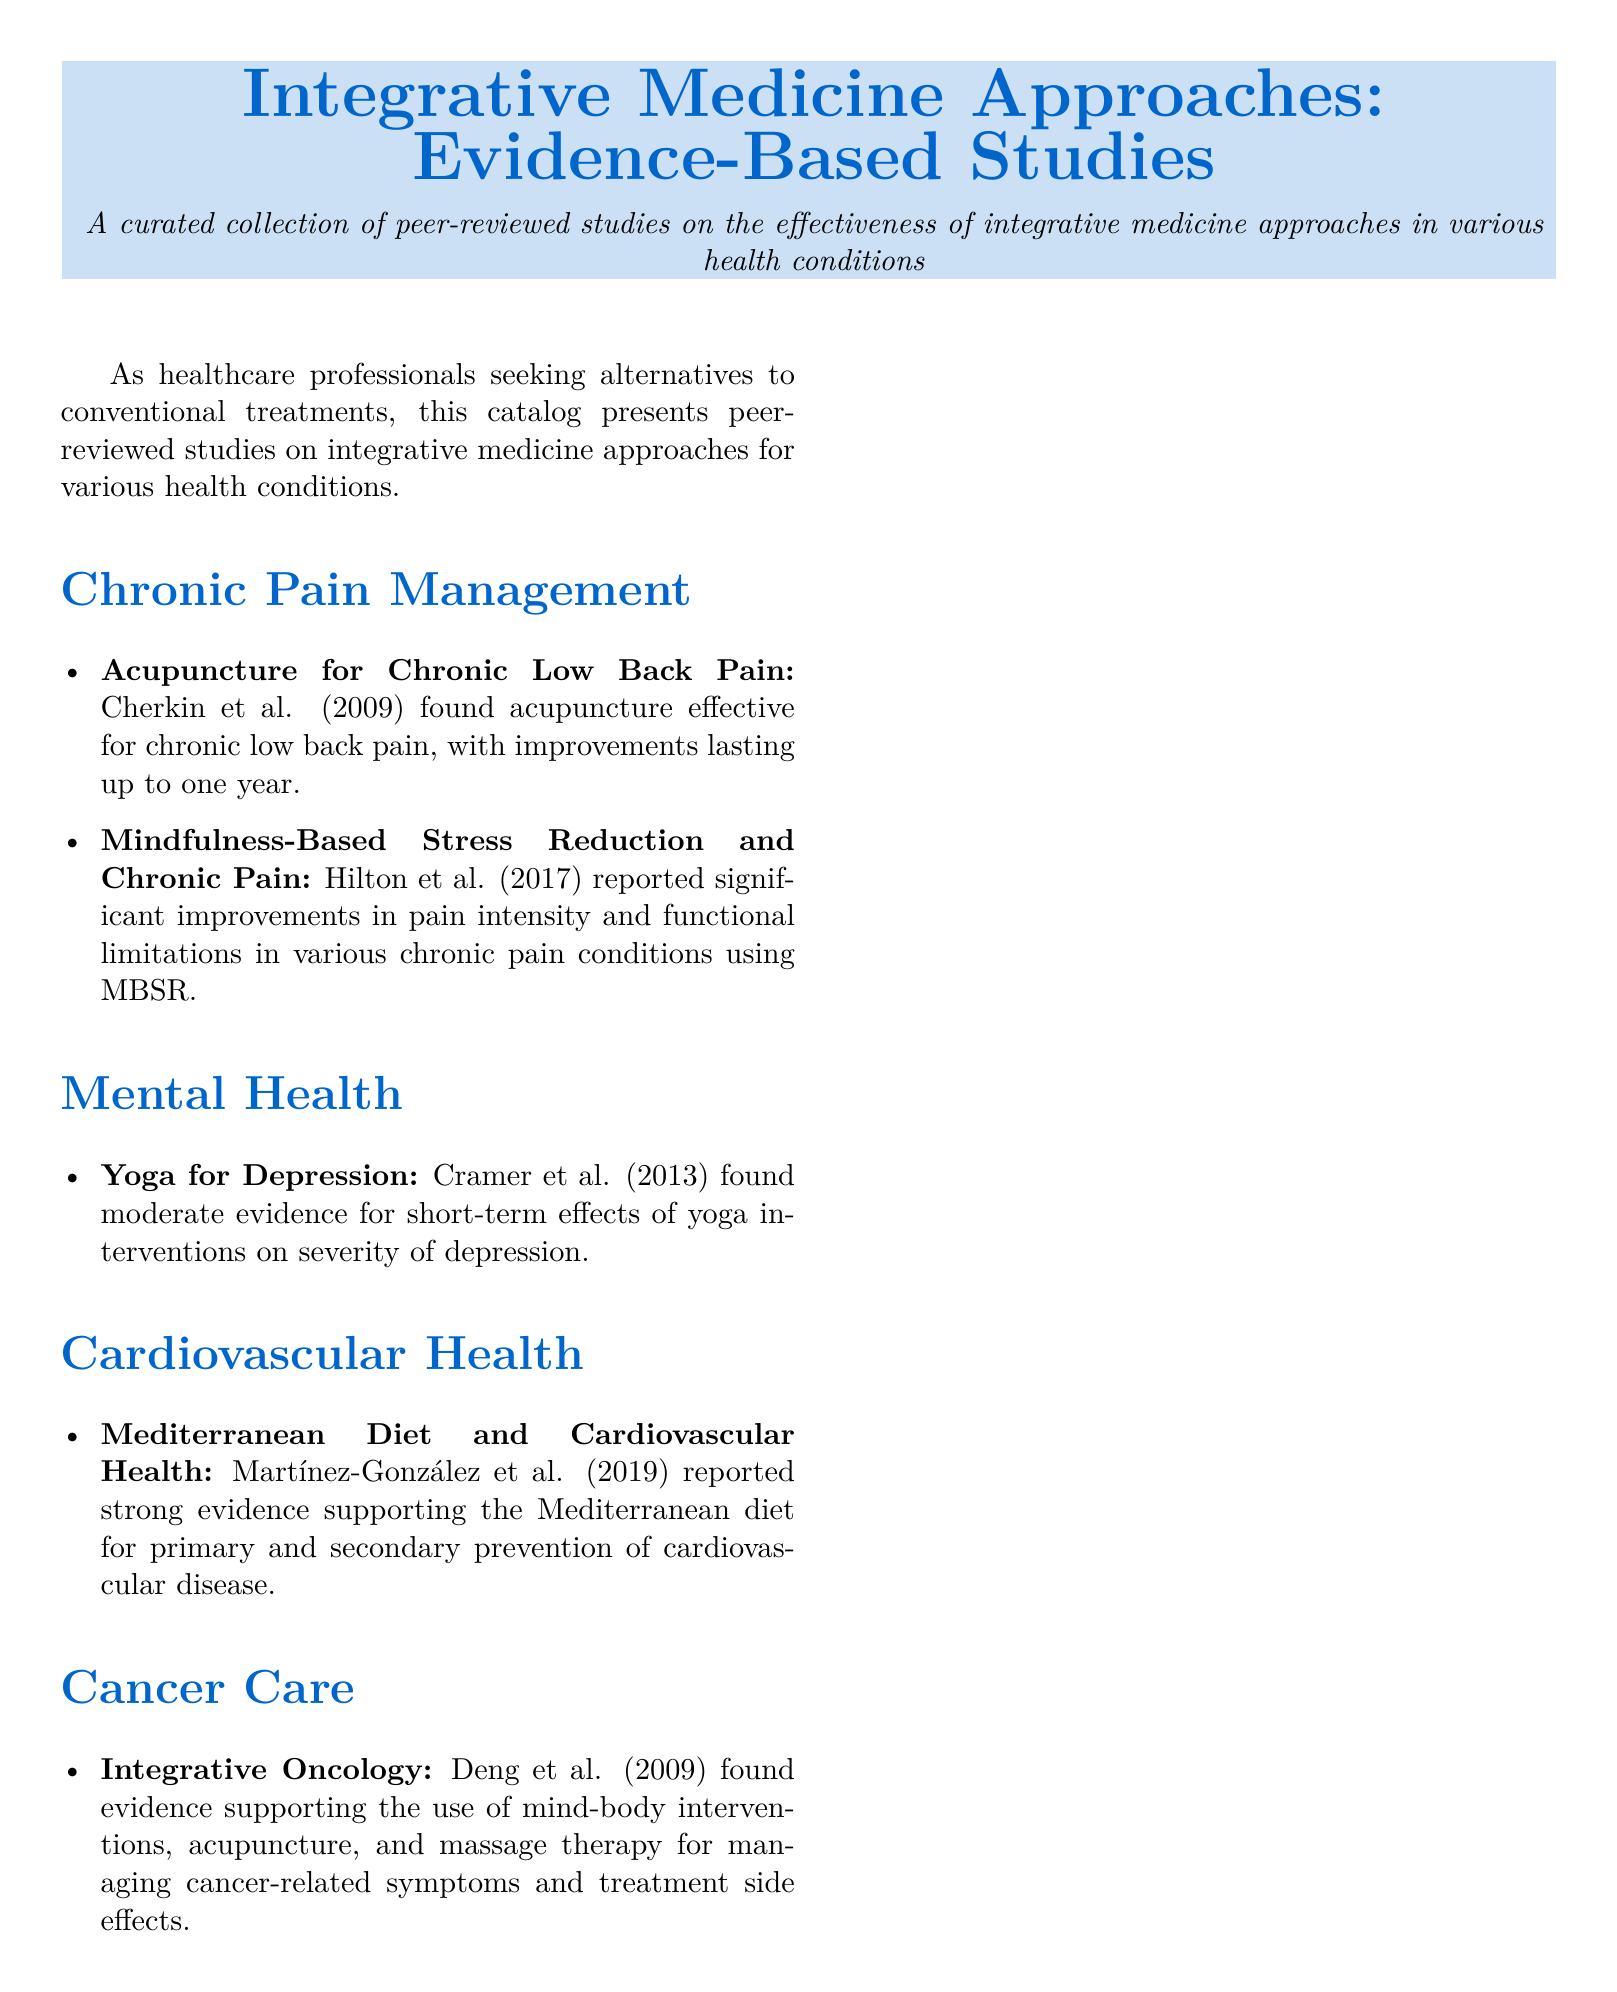what type of studies are included in the catalog? The catalog includes peer-reviewed studies on integrative medicine approaches.
Answer: peer-reviewed studies who conducted the study on acupuncture for chronic low back pain? The study on acupuncture for chronic low back pain was conducted by Cherkin et al.
Answer: Cherkin et al what year was the study by Martínez-González et al. published? The study by Martínez-González et al. was published in 2019.
Answer: 2019 which integrative medicine approach was found effective for managing cancer-related symptoms? The study by Deng et al. supports mind-body interventions, acupuncture, and massage therapy for managing cancer-related symptoms.
Answer: mind-body interventions, acupuncture, and massage therapy how many areas of health conditions are covered in the catalog? The catalog covers four areas of health conditions: chronic pain management, mental health, cardiovascular health, and cancer care.
Answer: four which diet was reported to have strong evidence for preventing cardiovascular disease? The Mediterranean diet was reported to have strong evidence for preventing cardiovascular disease.
Answer: Mediterranean diet what significant improvements were reported in Hilton et al.'s study? Hilton et al. reported significant improvements in pain intensity and functional limitations.
Answer: pain intensity and functional limitations what is the conclusion highlighted in the document? The conclusion emphasizes incorporating evidence-based integrative medicine approaches into patient care strategies.
Answer: incorporating evidence-based practices into patient care strategies 